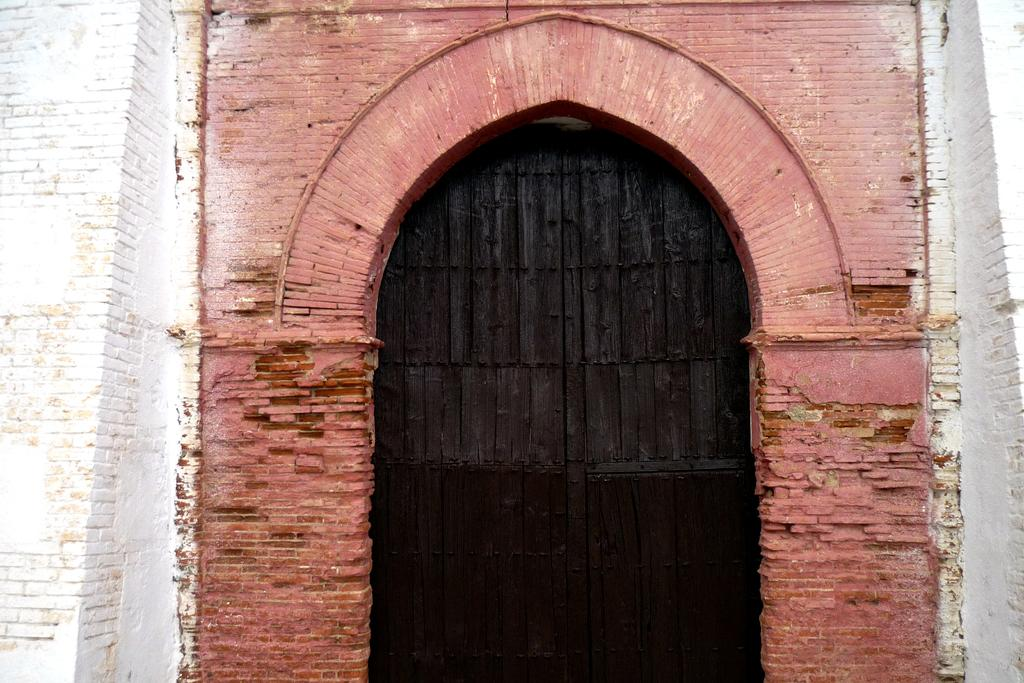What type of structure is present in the image? There is a building in the image. What material is the door of the building made of? The door of the building is made of wood. What thought is the building having in the image? Buildings do not have thoughts, so this question cannot be answered definitively from the image. 